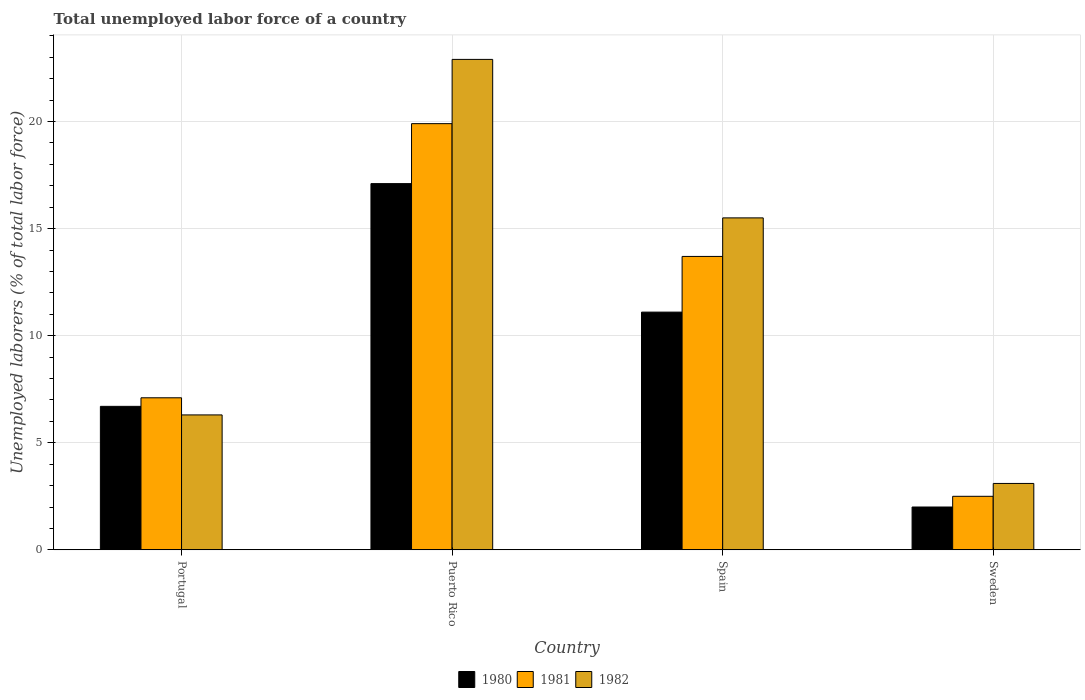How many different coloured bars are there?
Provide a succinct answer. 3. How many groups of bars are there?
Make the answer very short. 4. Are the number of bars on each tick of the X-axis equal?
Your answer should be compact. Yes. How many bars are there on the 1st tick from the left?
Your answer should be compact. 3. What is the label of the 2nd group of bars from the left?
Offer a terse response. Puerto Rico. Across all countries, what is the maximum total unemployed labor force in 1982?
Give a very brief answer. 22.9. Across all countries, what is the minimum total unemployed labor force in 1982?
Keep it short and to the point. 3.1. In which country was the total unemployed labor force in 1982 maximum?
Offer a very short reply. Puerto Rico. In which country was the total unemployed labor force in 1981 minimum?
Offer a terse response. Sweden. What is the total total unemployed labor force in 1981 in the graph?
Keep it short and to the point. 43.2. What is the difference between the total unemployed labor force in 1982 in Portugal and that in Sweden?
Your answer should be compact. 3.2. What is the difference between the total unemployed labor force in 1981 in Puerto Rico and the total unemployed labor force in 1980 in Spain?
Provide a succinct answer. 8.8. What is the average total unemployed labor force in 1981 per country?
Keep it short and to the point. 10.8. What is the difference between the total unemployed labor force of/in 1982 and total unemployed labor force of/in 1980 in Puerto Rico?
Keep it short and to the point. 5.8. In how many countries, is the total unemployed labor force in 1982 greater than 13 %?
Provide a succinct answer. 2. What is the ratio of the total unemployed labor force in 1981 in Puerto Rico to that in Spain?
Provide a short and direct response. 1.45. What is the difference between the highest and the second highest total unemployed labor force in 1981?
Offer a very short reply. 6.2. What is the difference between the highest and the lowest total unemployed labor force in 1982?
Make the answer very short. 19.8. In how many countries, is the total unemployed labor force in 1981 greater than the average total unemployed labor force in 1981 taken over all countries?
Your answer should be very brief. 2. Is the sum of the total unemployed labor force in 1981 in Portugal and Sweden greater than the maximum total unemployed labor force in 1982 across all countries?
Keep it short and to the point. No. What does the 2nd bar from the left in Puerto Rico represents?
Provide a short and direct response. 1981. What does the 3rd bar from the right in Sweden represents?
Your answer should be compact. 1980. Is it the case that in every country, the sum of the total unemployed labor force in 1981 and total unemployed labor force in 1980 is greater than the total unemployed labor force in 1982?
Provide a short and direct response. Yes. How many bars are there?
Keep it short and to the point. 12. Are all the bars in the graph horizontal?
Provide a succinct answer. No. How many countries are there in the graph?
Your answer should be very brief. 4. Are the values on the major ticks of Y-axis written in scientific E-notation?
Your response must be concise. No. Does the graph contain any zero values?
Keep it short and to the point. No. What is the title of the graph?
Offer a very short reply. Total unemployed labor force of a country. Does "2001" appear as one of the legend labels in the graph?
Your answer should be very brief. No. What is the label or title of the Y-axis?
Give a very brief answer. Unemployed laborers (% of total labor force). What is the Unemployed laborers (% of total labor force) in 1980 in Portugal?
Provide a short and direct response. 6.7. What is the Unemployed laborers (% of total labor force) of 1981 in Portugal?
Give a very brief answer. 7.1. What is the Unemployed laborers (% of total labor force) of 1982 in Portugal?
Your answer should be compact. 6.3. What is the Unemployed laborers (% of total labor force) in 1980 in Puerto Rico?
Offer a terse response. 17.1. What is the Unemployed laborers (% of total labor force) in 1981 in Puerto Rico?
Give a very brief answer. 19.9. What is the Unemployed laborers (% of total labor force) of 1982 in Puerto Rico?
Keep it short and to the point. 22.9. What is the Unemployed laborers (% of total labor force) of 1980 in Spain?
Your response must be concise. 11.1. What is the Unemployed laborers (% of total labor force) of 1981 in Spain?
Your response must be concise. 13.7. What is the Unemployed laborers (% of total labor force) in 1982 in Spain?
Your answer should be compact. 15.5. What is the Unemployed laborers (% of total labor force) of 1981 in Sweden?
Make the answer very short. 2.5. What is the Unemployed laborers (% of total labor force) in 1982 in Sweden?
Give a very brief answer. 3.1. Across all countries, what is the maximum Unemployed laborers (% of total labor force) of 1980?
Your answer should be very brief. 17.1. Across all countries, what is the maximum Unemployed laborers (% of total labor force) in 1981?
Ensure brevity in your answer.  19.9. Across all countries, what is the maximum Unemployed laborers (% of total labor force) in 1982?
Your answer should be compact. 22.9. Across all countries, what is the minimum Unemployed laborers (% of total labor force) in 1980?
Your answer should be very brief. 2. Across all countries, what is the minimum Unemployed laborers (% of total labor force) in 1982?
Offer a very short reply. 3.1. What is the total Unemployed laborers (% of total labor force) in 1980 in the graph?
Your response must be concise. 36.9. What is the total Unemployed laborers (% of total labor force) of 1981 in the graph?
Give a very brief answer. 43.2. What is the total Unemployed laborers (% of total labor force) of 1982 in the graph?
Make the answer very short. 47.8. What is the difference between the Unemployed laborers (% of total labor force) of 1981 in Portugal and that in Puerto Rico?
Provide a succinct answer. -12.8. What is the difference between the Unemployed laborers (% of total labor force) in 1982 in Portugal and that in Puerto Rico?
Give a very brief answer. -16.6. What is the difference between the Unemployed laborers (% of total labor force) of 1980 in Portugal and that in Spain?
Give a very brief answer. -4.4. What is the difference between the Unemployed laborers (% of total labor force) of 1981 in Portugal and that in Spain?
Your response must be concise. -6.6. What is the difference between the Unemployed laborers (% of total labor force) of 1982 in Portugal and that in Spain?
Your answer should be very brief. -9.2. What is the difference between the Unemployed laborers (% of total labor force) of 1981 in Portugal and that in Sweden?
Ensure brevity in your answer.  4.6. What is the difference between the Unemployed laborers (% of total labor force) of 1981 in Puerto Rico and that in Spain?
Offer a very short reply. 6.2. What is the difference between the Unemployed laborers (% of total labor force) in 1980 in Puerto Rico and that in Sweden?
Make the answer very short. 15.1. What is the difference between the Unemployed laborers (% of total labor force) in 1982 in Puerto Rico and that in Sweden?
Offer a very short reply. 19.8. What is the difference between the Unemployed laborers (% of total labor force) of 1980 in Spain and that in Sweden?
Your response must be concise. 9.1. What is the difference between the Unemployed laborers (% of total labor force) of 1981 in Spain and that in Sweden?
Ensure brevity in your answer.  11.2. What is the difference between the Unemployed laborers (% of total labor force) in 1980 in Portugal and the Unemployed laborers (% of total labor force) in 1982 in Puerto Rico?
Offer a terse response. -16.2. What is the difference between the Unemployed laborers (% of total labor force) in 1981 in Portugal and the Unemployed laborers (% of total labor force) in 1982 in Puerto Rico?
Ensure brevity in your answer.  -15.8. What is the difference between the Unemployed laborers (% of total labor force) in 1980 in Portugal and the Unemployed laborers (% of total labor force) in 1981 in Spain?
Give a very brief answer. -7. What is the difference between the Unemployed laborers (% of total labor force) of 1981 in Portugal and the Unemployed laborers (% of total labor force) of 1982 in Spain?
Keep it short and to the point. -8.4. What is the difference between the Unemployed laborers (% of total labor force) of 1980 in Puerto Rico and the Unemployed laborers (% of total labor force) of 1982 in Spain?
Your response must be concise. 1.6. What is the difference between the Unemployed laborers (% of total labor force) of 1980 in Puerto Rico and the Unemployed laborers (% of total labor force) of 1982 in Sweden?
Make the answer very short. 14. What is the difference between the Unemployed laborers (% of total labor force) in 1980 in Spain and the Unemployed laborers (% of total labor force) in 1982 in Sweden?
Provide a short and direct response. 8. What is the difference between the Unemployed laborers (% of total labor force) of 1981 in Spain and the Unemployed laborers (% of total labor force) of 1982 in Sweden?
Your answer should be very brief. 10.6. What is the average Unemployed laborers (% of total labor force) of 1980 per country?
Provide a succinct answer. 9.22. What is the average Unemployed laborers (% of total labor force) of 1982 per country?
Make the answer very short. 11.95. What is the difference between the Unemployed laborers (% of total labor force) of 1980 and Unemployed laborers (% of total labor force) of 1982 in Portugal?
Make the answer very short. 0.4. What is the difference between the Unemployed laborers (% of total labor force) of 1981 and Unemployed laborers (% of total labor force) of 1982 in Portugal?
Offer a very short reply. 0.8. What is the difference between the Unemployed laborers (% of total labor force) of 1980 and Unemployed laborers (% of total labor force) of 1981 in Puerto Rico?
Provide a succinct answer. -2.8. What is the difference between the Unemployed laborers (% of total labor force) in 1980 and Unemployed laborers (% of total labor force) in 1982 in Puerto Rico?
Offer a terse response. -5.8. What is the difference between the Unemployed laborers (% of total labor force) in 1980 and Unemployed laborers (% of total labor force) in 1981 in Sweden?
Make the answer very short. -0.5. What is the ratio of the Unemployed laborers (% of total labor force) in 1980 in Portugal to that in Puerto Rico?
Provide a succinct answer. 0.39. What is the ratio of the Unemployed laborers (% of total labor force) of 1981 in Portugal to that in Puerto Rico?
Offer a very short reply. 0.36. What is the ratio of the Unemployed laborers (% of total labor force) of 1982 in Portugal to that in Puerto Rico?
Give a very brief answer. 0.28. What is the ratio of the Unemployed laborers (% of total labor force) in 1980 in Portugal to that in Spain?
Provide a succinct answer. 0.6. What is the ratio of the Unemployed laborers (% of total labor force) in 1981 in Portugal to that in Spain?
Provide a short and direct response. 0.52. What is the ratio of the Unemployed laborers (% of total labor force) of 1982 in Portugal to that in Spain?
Your response must be concise. 0.41. What is the ratio of the Unemployed laborers (% of total labor force) in 1980 in Portugal to that in Sweden?
Your response must be concise. 3.35. What is the ratio of the Unemployed laborers (% of total labor force) in 1981 in Portugal to that in Sweden?
Your answer should be compact. 2.84. What is the ratio of the Unemployed laborers (% of total labor force) in 1982 in Portugal to that in Sweden?
Your answer should be very brief. 2.03. What is the ratio of the Unemployed laborers (% of total labor force) in 1980 in Puerto Rico to that in Spain?
Provide a short and direct response. 1.54. What is the ratio of the Unemployed laborers (% of total labor force) in 1981 in Puerto Rico to that in Spain?
Offer a very short reply. 1.45. What is the ratio of the Unemployed laborers (% of total labor force) of 1982 in Puerto Rico to that in Spain?
Provide a short and direct response. 1.48. What is the ratio of the Unemployed laborers (% of total labor force) in 1980 in Puerto Rico to that in Sweden?
Your answer should be very brief. 8.55. What is the ratio of the Unemployed laborers (% of total labor force) in 1981 in Puerto Rico to that in Sweden?
Ensure brevity in your answer.  7.96. What is the ratio of the Unemployed laborers (% of total labor force) in 1982 in Puerto Rico to that in Sweden?
Your answer should be compact. 7.39. What is the ratio of the Unemployed laborers (% of total labor force) in 1980 in Spain to that in Sweden?
Provide a short and direct response. 5.55. What is the ratio of the Unemployed laborers (% of total labor force) in 1981 in Spain to that in Sweden?
Make the answer very short. 5.48. What is the difference between the highest and the lowest Unemployed laborers (% of total labor force) of 1981?
Give a very brief answer. 17.4. What is the difference between the highest and the lowest Unemployed laborers (% of total labor force) in 1982?
Give a very brief answer. 19.8. 